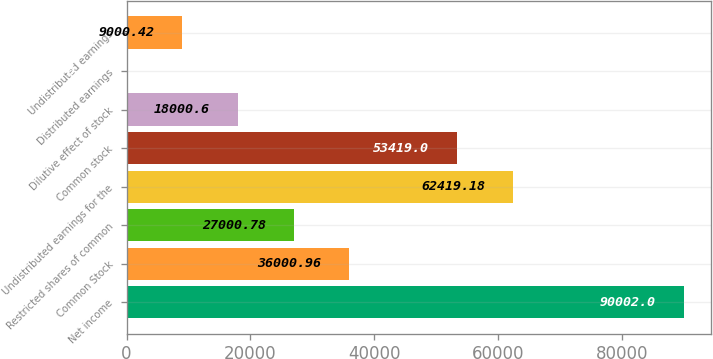Convert chart to OTSL. <chart><loc_0><loc_0><loc_500><loc_500><bar_chart><fcel>Net income<fcel>Common Stock<fcel>Restricted shares of common<fcel>Undistributed earnings for the<fcel>Common stock<fcel>Dilutive effect of stock<fcel>Distributed earnings<fcel>Undistributed earnings<nl><fcel>90002<fcel>36001<fcel>27000.8<fcel>62419.2<fcel>53419<fcel>18000.6<fcel>0.24<fcel>9000.42<nl></chart> 